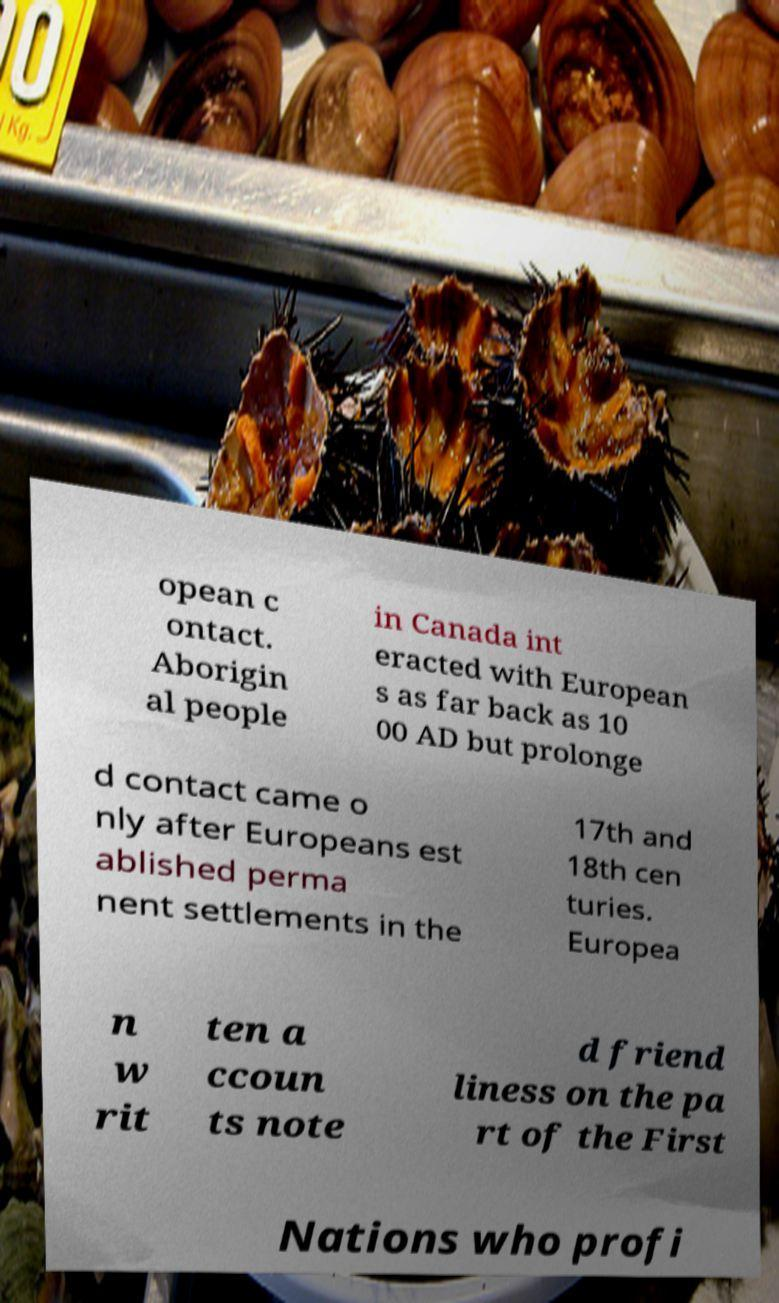Please read and relay the text visible in this image. What does it say? opean c ontact. Aborigin al people in Canada int eracted with European s as far back as 10 00 AD but prolonge d contact came o nly after Europeans est ablished perma nent settlements in the 17th and 18th cen turies. Europea n w rit ten a ccoun ts note d friend liness on the pa rt of the First Nations who profi 